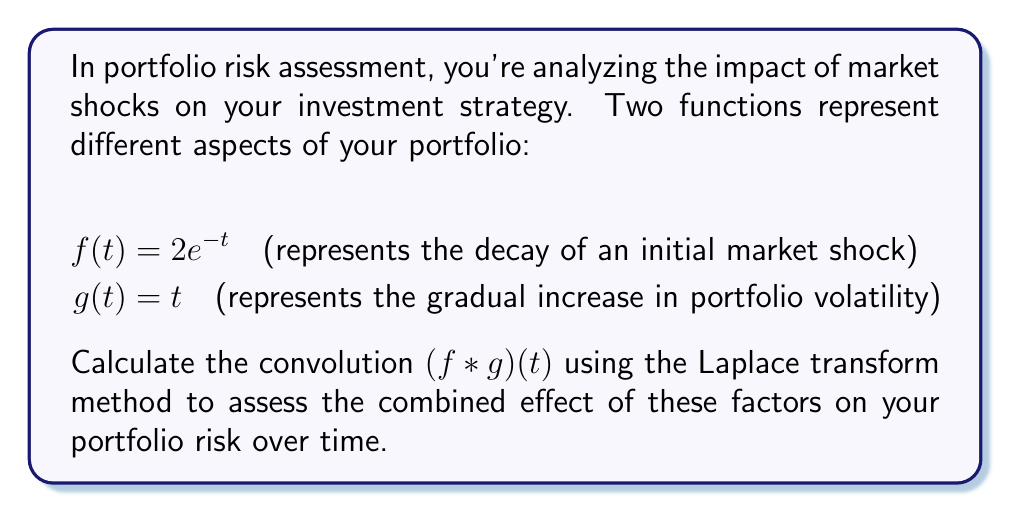Provide a solution to this math problem. To solve this problem using the Laplace transform method, we'll follow these steps:

1) First, let's recall the convolution theorem:
   $\mathcal{L}\{f * g\} = \mathcal{L}\{f\} \cdot \mathcal{L}\{g\}$

2) Calculate the Laplace transform of $f(t)$:
   $\mathcal{L}\{f(t)\} = \mathcal{L}\{2e^{-t}\} = \frac{2}{s+1}$

3) Calculate the Laplace transform of $g(t)$:
   $\mathcal{L}\{g(t)\} = \mathcal{L}\{t\} = \frac{1}{s^2}$

4) Multiply the Laplace transforms:
   $\mathcal{L}\{f * g\} = \frac{2}{s+1} \cdot \frac{1}{s^2} = \frac{2}{s^2(s+1)}$

5) Use partial fraction decomposition:
   $\frac{2}{s^2(s+1)} = \frac{A}{s} + \frac{B}{s^2} + \frac{C}{s+1}$

   Solving for A, B, and C:
   $A = 2$
   $B = -2$
   $C = -2$

   So, $\frac{2}{s^2(s+1)} = \frac{2}{s} - \frac{2}{s^2} - \frac{2}{s+1}$

6) Take the inverse Laplace transform:
   $\mathcal{L}^{-1}\{\frac{2}{s}\} = 2$
   $\mathcal{L}^{-1}\{-\frac{2}{s^2}\} = -2t$
   $\mathcal{L}^{-1}\{-\frac{2}{s+1}\} = -2e^{-t}$

7) Sum these terms to get the final result:
   $(f * g)(t) = 2 - 2t - 2e^{-t}$

This result represents the combined effect of the initial market shock decay and the gradual increase in portfolio volatility over time.
Answer: $(f * g)(t) = 2 - 2t - 2e^{-t}$ 